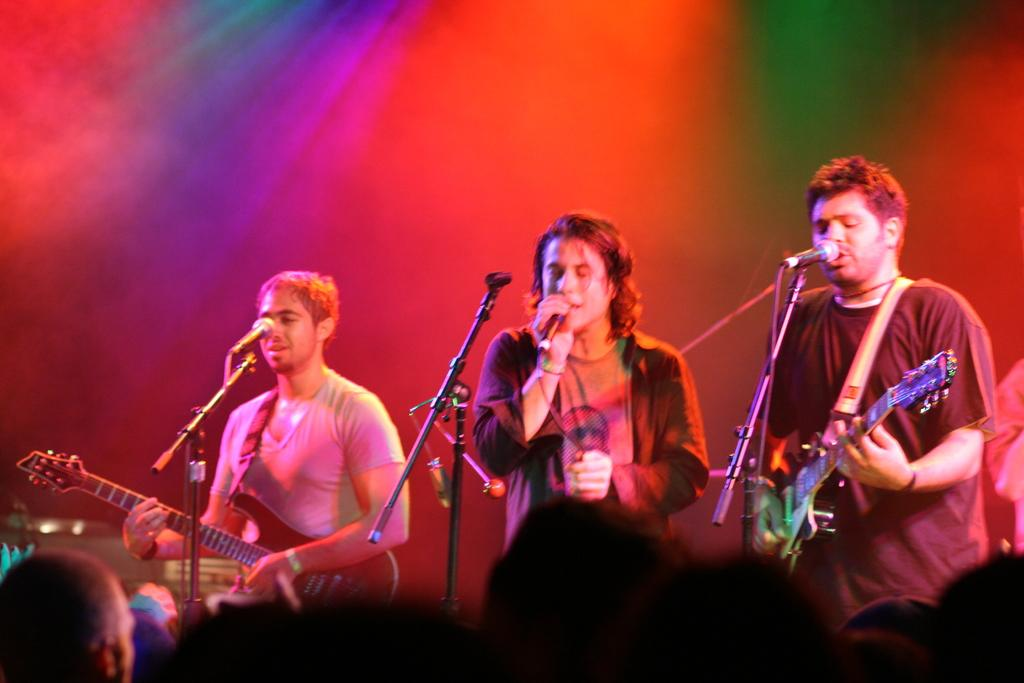What are the people in the image doing? The people in the image are standing, and some of them are holding guitars. Is there anyone in the image with a microphone? Yes, there is a person holding a microphone in the image. What can be seen in front of the people? There are microphones in front of the people. What type of horn can be seen on the person holding the microphone? There is no horn visible on the person holding the microphone in the image. How does the cork affect the performance of the people in the image? There is no cork present in the image, so it cannot affect the performance of the people. 